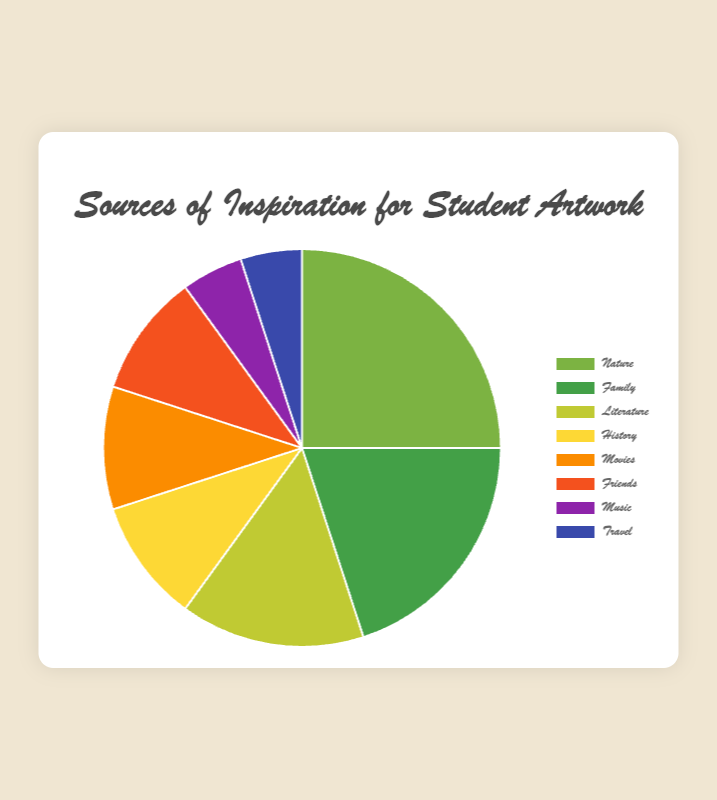Which source of inspiration has the highest percentage? By looking at the pie chart, identify the segment that takes up the largest portion. The "Nature" segment is visibly the largest.
Answer: Nature Which sources contribute equally in percentage? Identify the segments that are of equal size in the chart. Both "History", "Movies", and "Friends" segments share the same space in the pie chart, each taking up 10%.
Answer: History, Movies, Friends What is the total percentage contributed by "Music" and "Travel"? Find the segments labeled "Music" and "Travel" and sum their percentages (5% and 5%). So, 5 + 5 = 10.
Answer: 10 Which two sources have the smallest percentage? Look at the smallest segments of the pie chart. The "Music" and "Travel" segments are the smallest, each taking up 5%.
Answer: Music, Travel Is "Family" a stronger source of inspiration than "Movies"? Compare the sizes of the "Family" and "Movies" segments. "Family" has 20% while "Movies" has 10%.
Answer: Yes What is the difference in percentage between "Family" and "Literature"? Subtract the percentage of "Literature" from "Family" (20% - 15%). So, 20 - 15 = 5.
Answer: 5 How much more inspiration is taken from "Nature" compared to "Friends" according to the chart? Subtract the percentage of "Friends" from "Nature" (25% - 10%). So, 25 - 10 = 15.
Answer: 15 What percentage of the inspiration sources comes from "Nature", "Family", and "Literature" combined? Add the percentages of "Nature", "Family", and "Literature" (25% + 20% + 15%). So, 25 + 20 + 15 = 60.
Answer: 60 